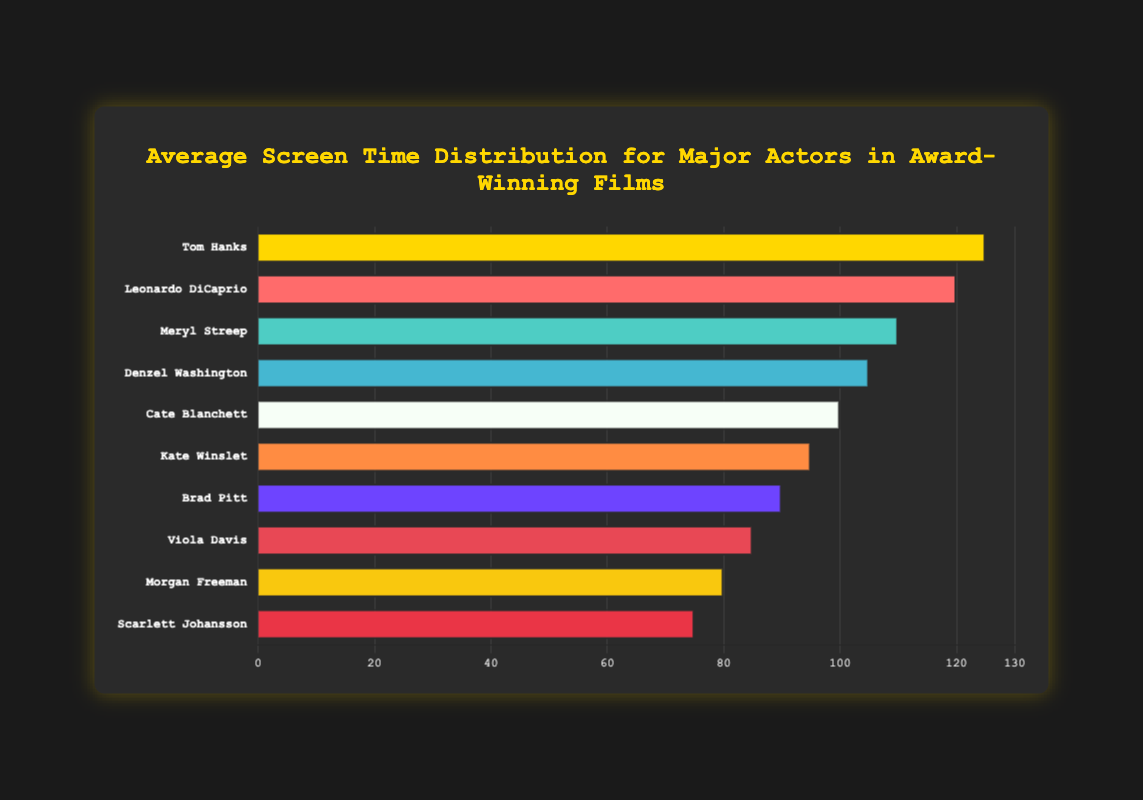Which actor has the longest average screen time? The actor with the longest bar represents the actor with the highest average screen time. Look at the bar reaching the furthest on the x-axis. Tom Hanks has the longest average screen time with 125 minutes.
Answer: Tom Hanks Who has more average screen time, Leonardo DiCaprio or Morgan Freeman? Compare the lengths of the bars for both actors. Leonardo DiCaprio has an average screen time of 120 minutes, while Morgan Freeman has 80 minutes.
Answer: Leonardo DiCaprio How much longer is Tom Hanks' average screen time compared to Scarlett Johansson's? Subtract Scarlett Johansson's average screen time from Tom Hanks'. Tom Hanks has 125 minutes and Scarlett Johansson has 75 minutes. 125 - 75 = 50 minutes.
Answer: 50 minutes What is the total average screen time for Meryl Streep and Denzel Washington combined? Add the average screen times of Meryl Streep and Denzel Washington. Meryl Streep has 110 minutes and Denzel Washington has 105 minutes. 110 + 105 = 215 minutes.
Answer: 215 minutes Which two actors have the closest average screen times? Compare the bar lengths of all actors to find two bars that are closest in length. Leonardo DiCaprio and Meryl Streep have average screen times of 120 and 110 minutes, respectively, with a difference of only 10 minutes.
Answer: Leonardo DiCaprio and Meryl Streep Is Cate Blanchett’s average screen time greater than, less than, or equal to Kate Winslet’s? Compare the lengths of Cate Blanchett’s and Kate Winslet’s bars. Cate Blanchett has an average screen time of 100 minutes, which is greater than Kate Winslet’s 95 minutes.
Answer: Greater than What is the average screen time for Brad Pitt and Viola Davis together? Add the average screen times of Brad Pitt and Viola Davis, then divide by 2. Brad Pitt has 90 minutes and Viola Davis has 85 minutes. (90 + 85) / 2 = 87.5 minutes.
Answer: 87.5 minutes Which actor has the second least average screen time? Look for the second shortest bar on the chart. Scarlett Johansson has the least average screen time with 75 minutes, and Morgan Freeman has the second least with 80 minutes.
Answer: Morgan Freeman What is the difference in average screen time between the actor with the highest and the actor with the lowest time? Subtract the shortest average screen time from the longest. Tom Hanks has 125 minutes, and Scarlett Johansson has 75 minutes. 125 - 75 = 50 minutes.
Answer: 50 minutes 